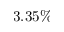<formula> <loc_0><loc_0><loc_500><loc_500>3 . 3 5 \%</formula> 